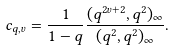<formula> <loc_0><loc_0><loc_500><loc_500>c _ { q , v } = \frac { 1 } { 1 - q } \frac { ( q ^ { 2 v + 2 } , q ^ { 2 } ) _ { \infty } } { ( q ^ { 2 } , q ^ { 2 } ) _ { \infty } } .</formula> 